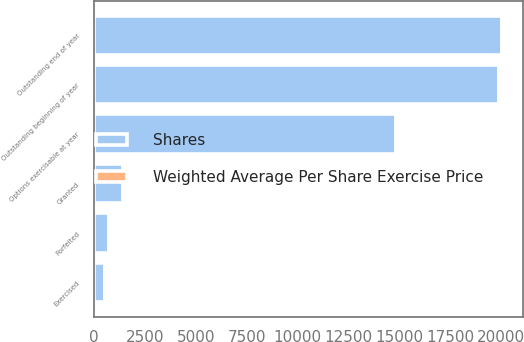<chart> <loc_0><loc_0><loc_500><loc_500><stacked_bar_chart><ecel><fcel>Outstanding beginning of year<fcel>Granted<fcel>Exercised<fcel>Forfeited<fcel>Outstanding end of year<fcel>Options exercisable at year<nl><fcel>Shares<fcel>19884<fcel>1430<fcel>528<fcel>727<fcel>20059<fcel>14857<nl><fcel>Weighted Average Per Share Exercise Price<fcel>20<fcel>11<fcel>8<fcel>23<fcel>19<fcel>20<nl></chart> 